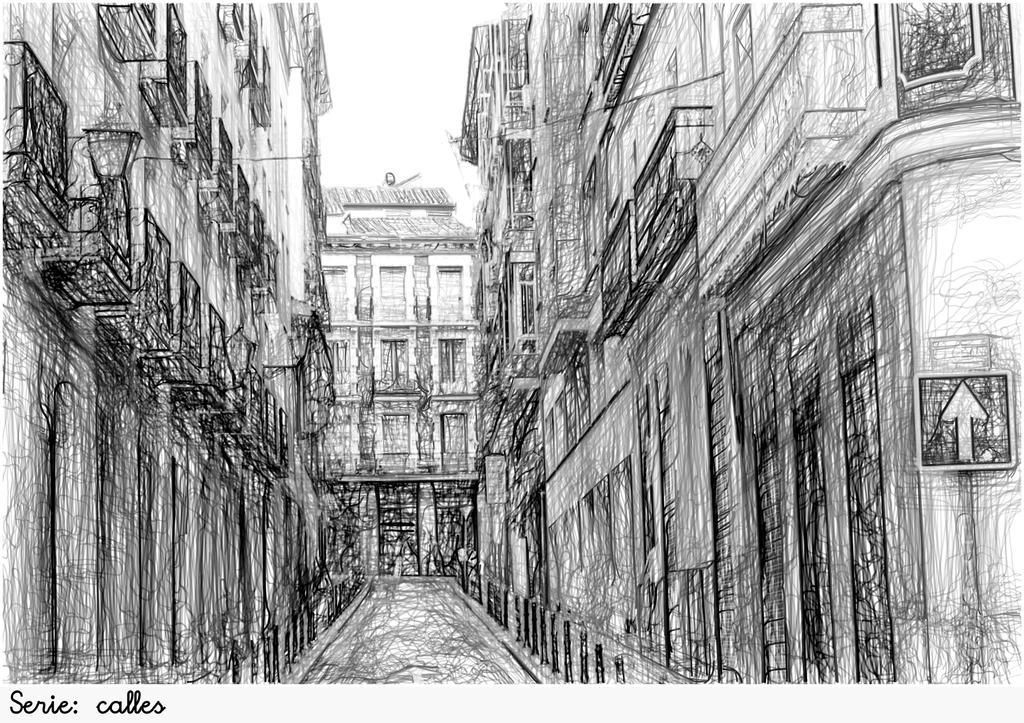Can you describe this image briefly? In this image I can see the pencil sketch of few buildings, the road, a sign board, a street light and few wires. In the background I can see the sky. 